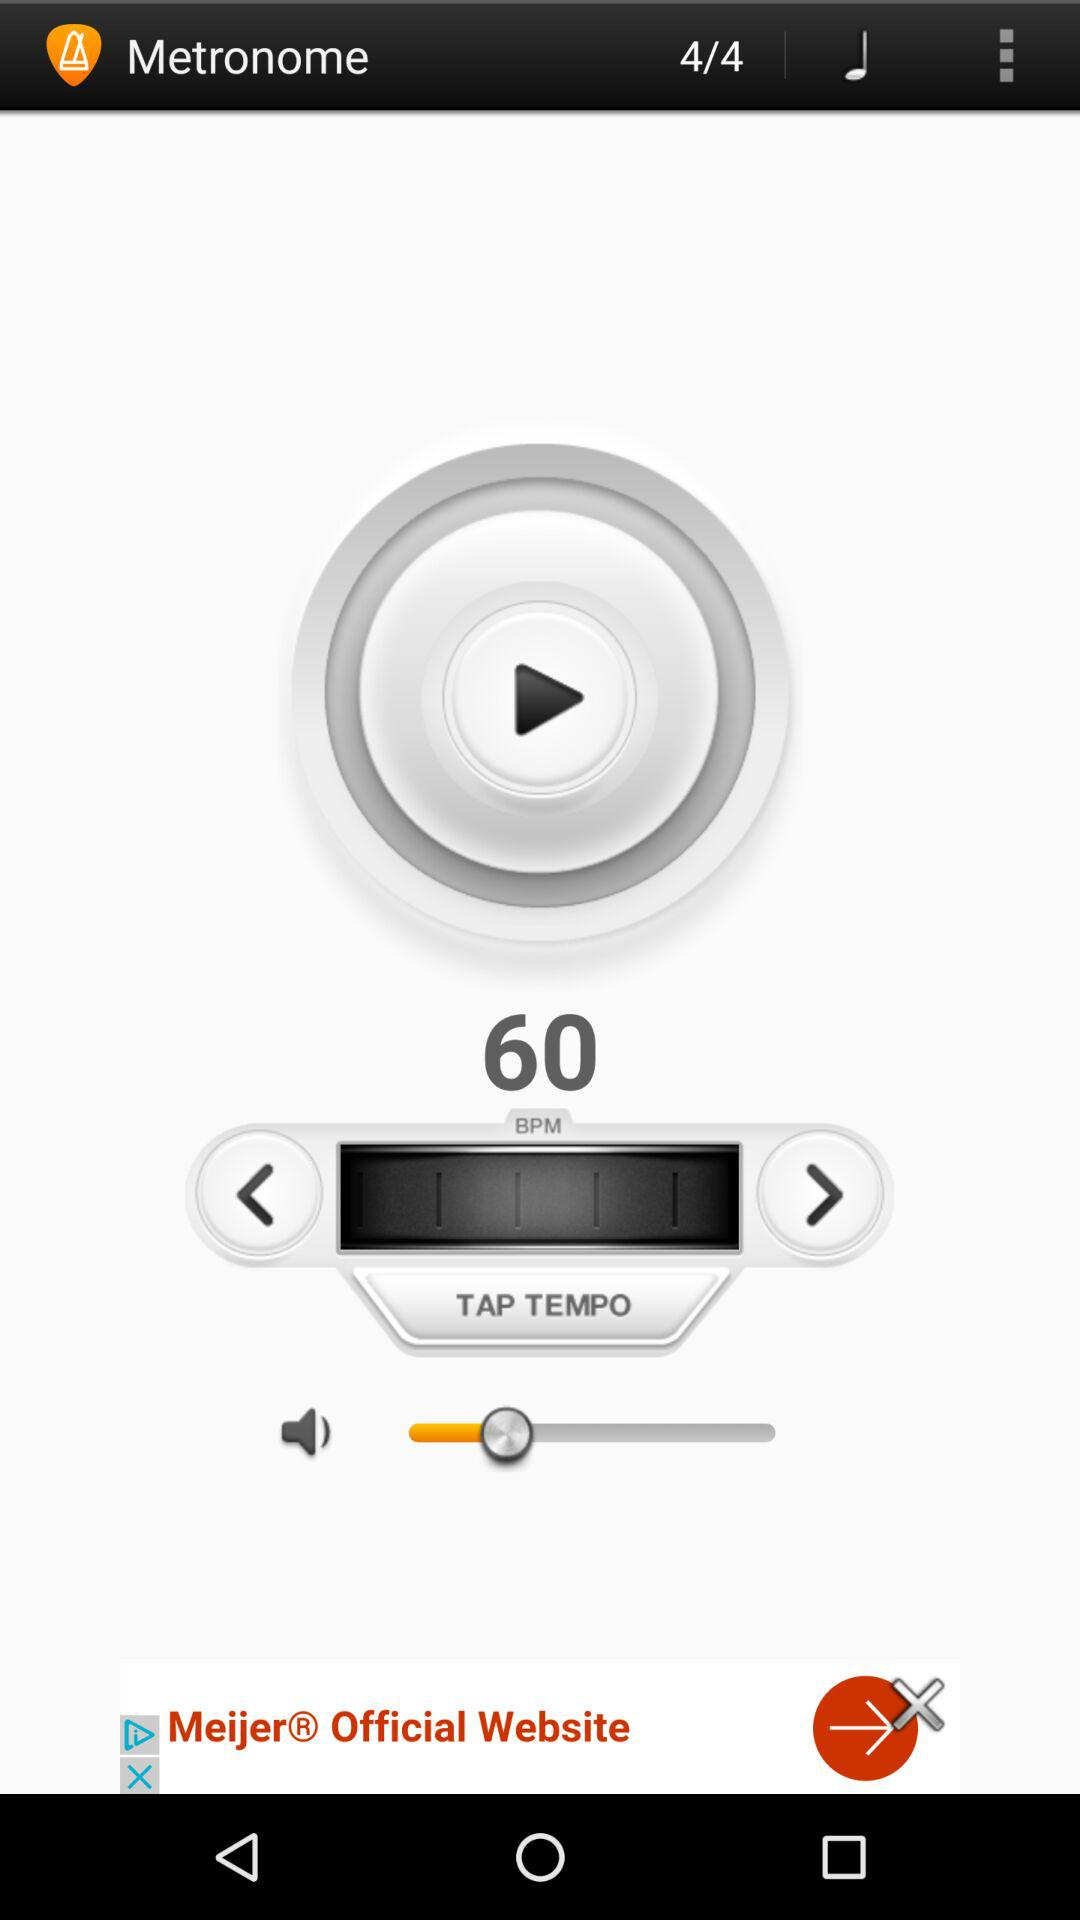What is the name of the application? The name of the application is "Metronome". 